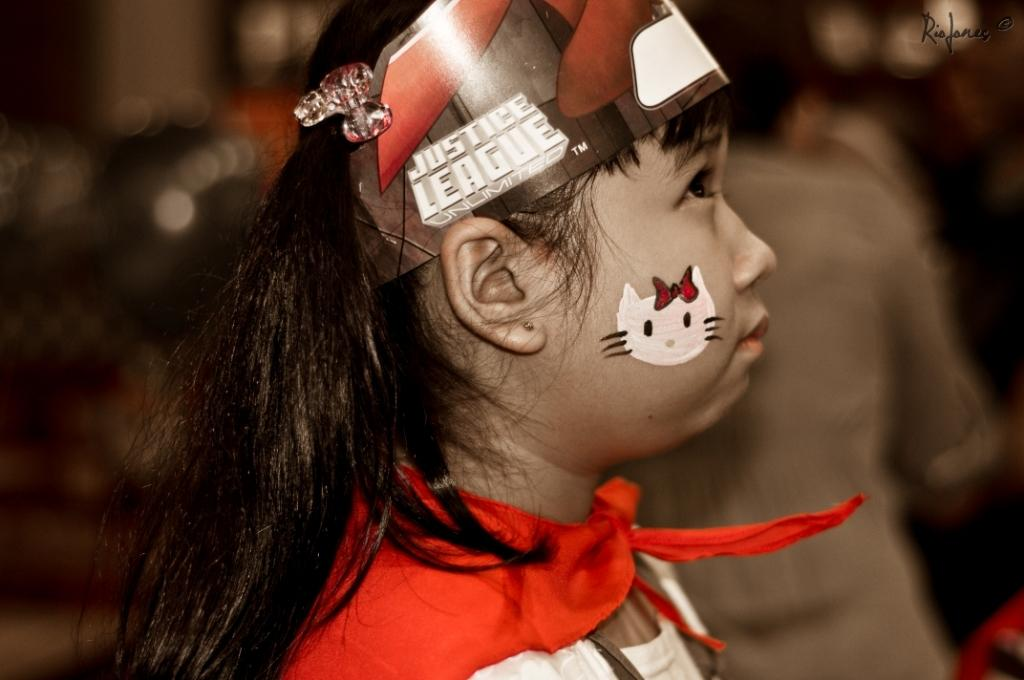Who is the main subject in the image? There is a girl in the image. Can you describe the background of the image? The background of the image is blurred. What type of wheel can be seen in the image? There is no wheel present in the image. Can you describe the relationship between the girl and the stranger in the image? There is no stranger present in the image, so it is not possible to describe their relationship. 